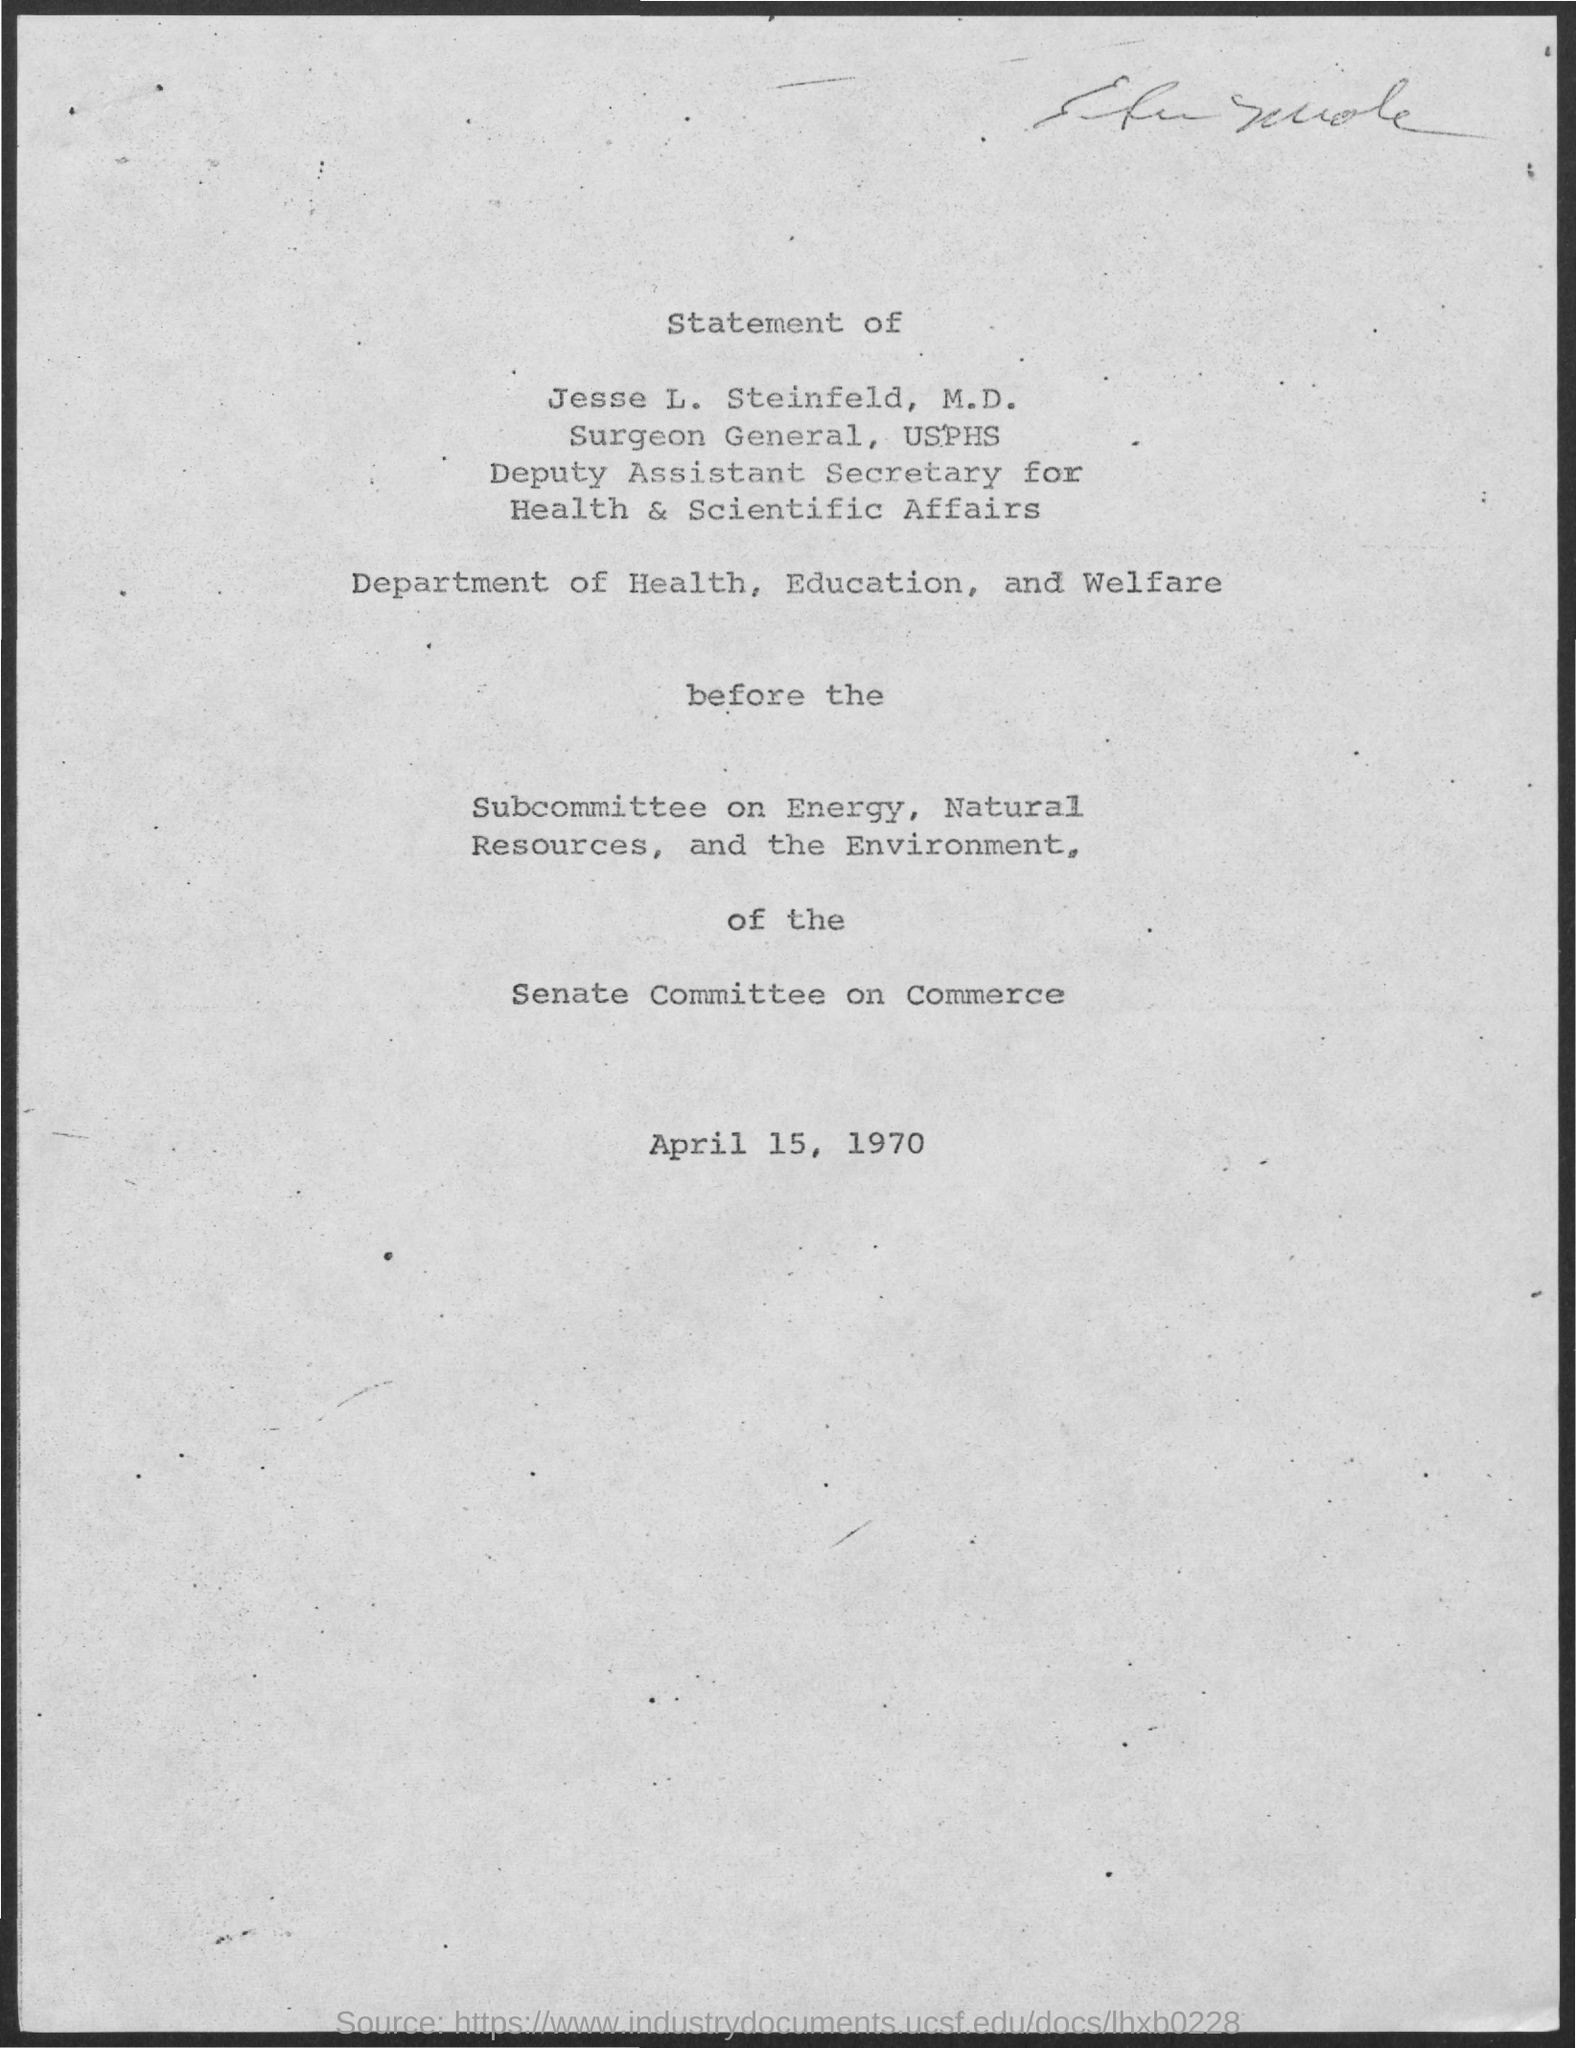Specify some key components in this picture. The department mentioned is the Department of Health, Education, and Welfare. The date mentioned in the given page is April 15, 1970. 